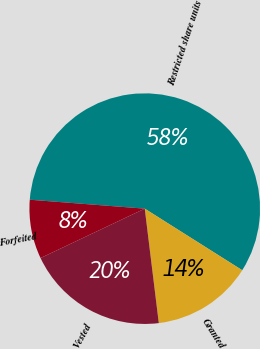Convert chart. <chart><loc_0><loc_0><loc_500><loc_500><pie_chart><fcel>Restricted share units<fcel>Granted<fcel>Vested<fcel>Forfeited<nl><fcel>57.73%<fcel>14.09%<fcel>19.9%<fcel>8.28%<nl></chart> 